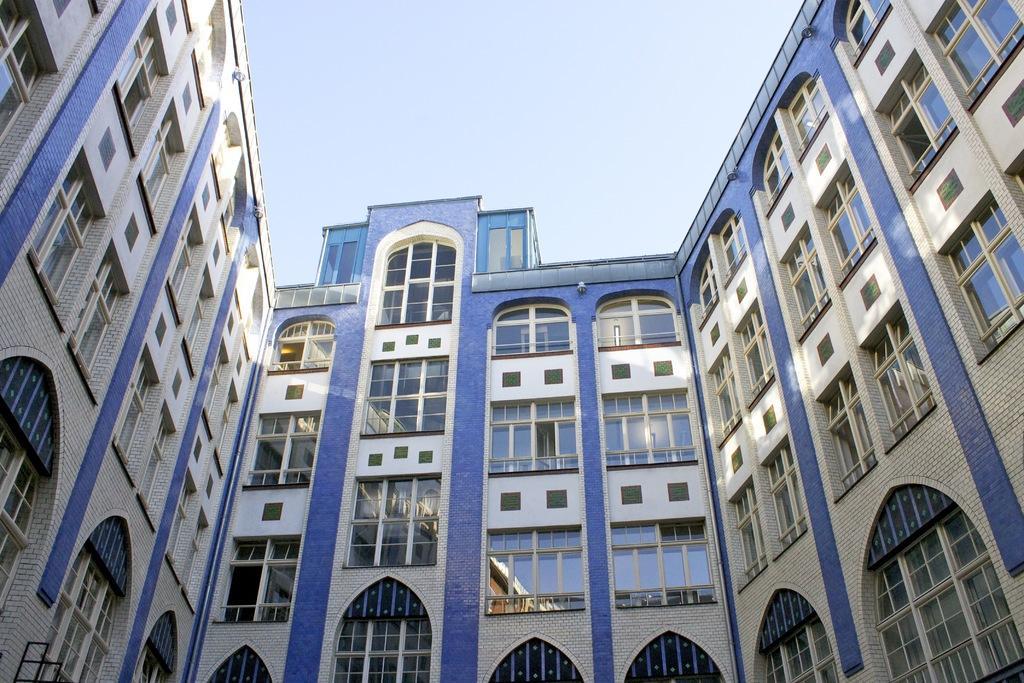Could you give a brief overview of what you see in this image? In this picture we can see buildings with windows and in the background we can see the sky. 